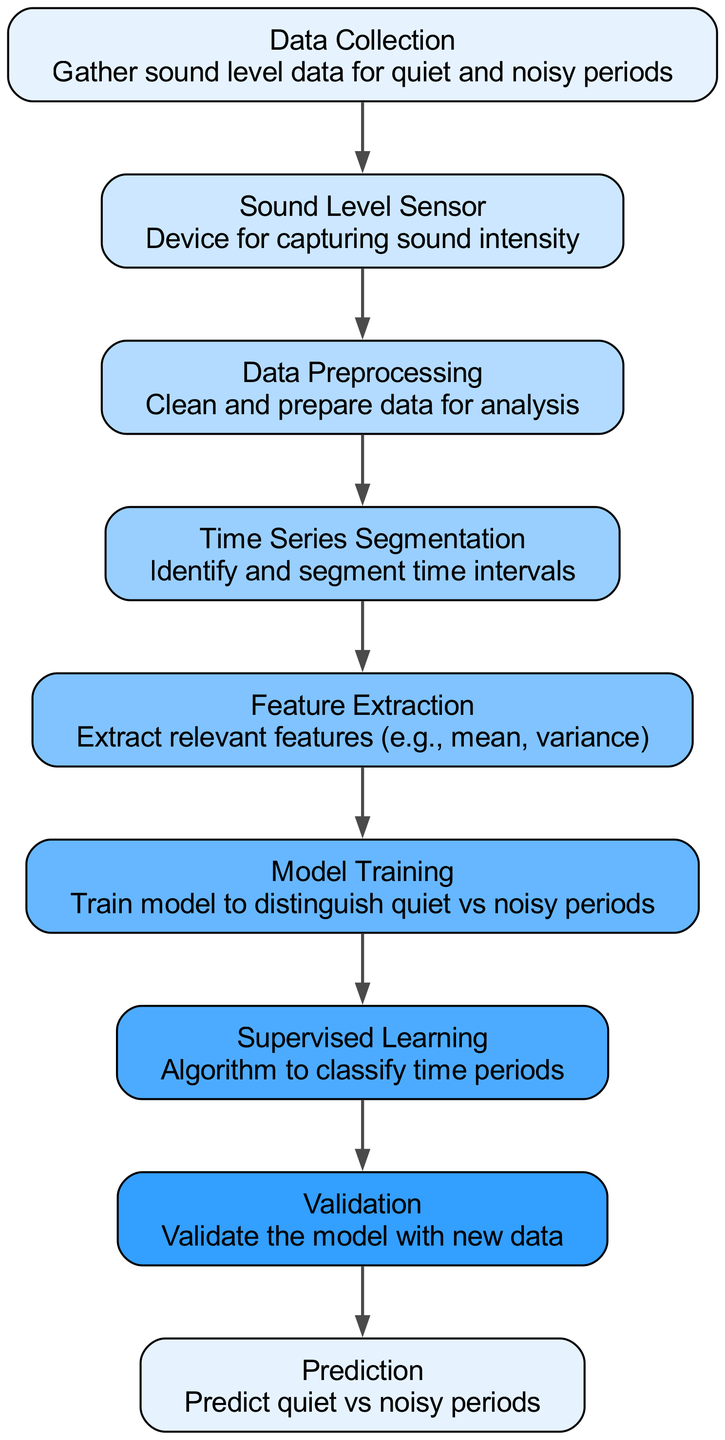What is the total number of nodes in the diagram? The diagram contains a total of 9 nodes, as listed in the provided data. Each node corresponds to a specific stage in the machine learning process for time series analysis.
Answer: 9 What follows after Data Preprocessing? After "Data Preprocessing," the next node is "Time Series Segmentation," showing the progression of the analysis process.
Answer: Time Series Segmentation Which node is responsible for capturing sound intensity? The node named "Sound Level Sensor" is explicitly mentioned as the device that captures sound intensity, making it the key component for the initial data collection phase.
Answer: Sound Level Sensor How many edges connect the nodes in the diagram? The diagram has 8 edges, which represent the connections between the 9 nodes, illustrating the flow of data and processes throughout the analysis pipeline.
Answer: 8 What feature is not directly extracted in Feature Extraction? The node "Feature Extraction" specifically lists extracting features like mean and variance, implying that "sound frequency" and "sound source" are not included, as they aren't mentioned in the details.
Answer: Sound frequency What is the purpose of the Supervised Learning node? The purpose of the "Supervised Learning" node is to classify time periods as quiet or noisy by utilizing the model trained during the previous step, which re-emphasizes its role in the learning process.
Answer: Classify time periods Which step in the diagram is likely to involve new data for testing? The "Validation" step is the phase in the diagram that indicates the use of new data for testing the performance of the trained model, thus ensuring its effectiveness.
Answer: Validation What happens after the model is trained? Following the "Model Training", the next step is "Supervised Learning," where the trained model is applied to classify periods based on their sound characteristics.
Answer: Supervised Learning Which node defines how sound data is organized into intervals? The "Time Series Segmentation" node is responsible for defining how the sound data is organized into time intervals, essentially breaking down the data for better analysis.
Answer: Time Series Segmentation 